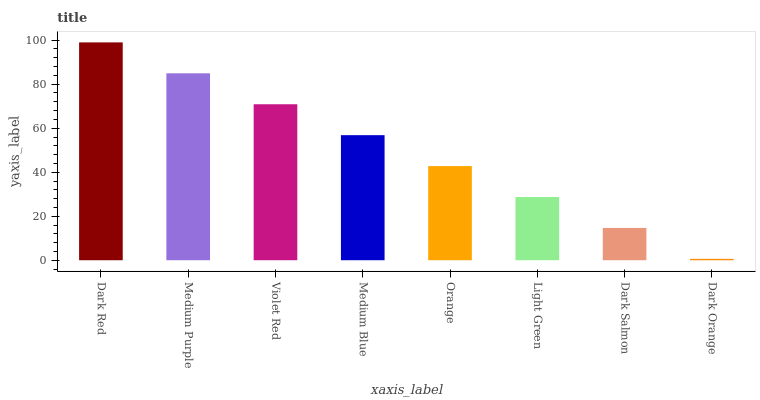Is Medium Purple the minimum?
Answer yes or no. No. Is Medium Purple the maximum?
Answer yes or no. No. Is Dark Red greater than Medium Purple?
Answer yes or no. Yes. Is Medium Purple less than Dark Red?
Answer yes or no. Yes. Is Medium Purple greater than Dark Red?
Answer yes or no. No. Is Dark Red less than Medium Purple?
Answer yes or no. No. Is Medium Blue the high median?
Answer yes or no. Yes. Is Orange the low median?
Answer yes or no. Yes. Is Dark Red the high median?
Answer yes or no. No. Is Violet Red the low median?
Answer yes or no. No. 